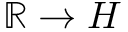<formula> <loc_0><loc_0><loc_500><loc_500>\mathbb { R } \to H</formula> 